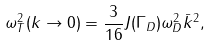<formula> <loc_0><loc_0><loc_500><loc_500>\omega _ { T } ^ { 2 } ( k \to 0 ) = \frac { 3 } { 1 6 } J ( \Gamma _ { D } ) \omega _ { D } ^ { 2 } \bar { k } ^ { 2 } ,</formula> 